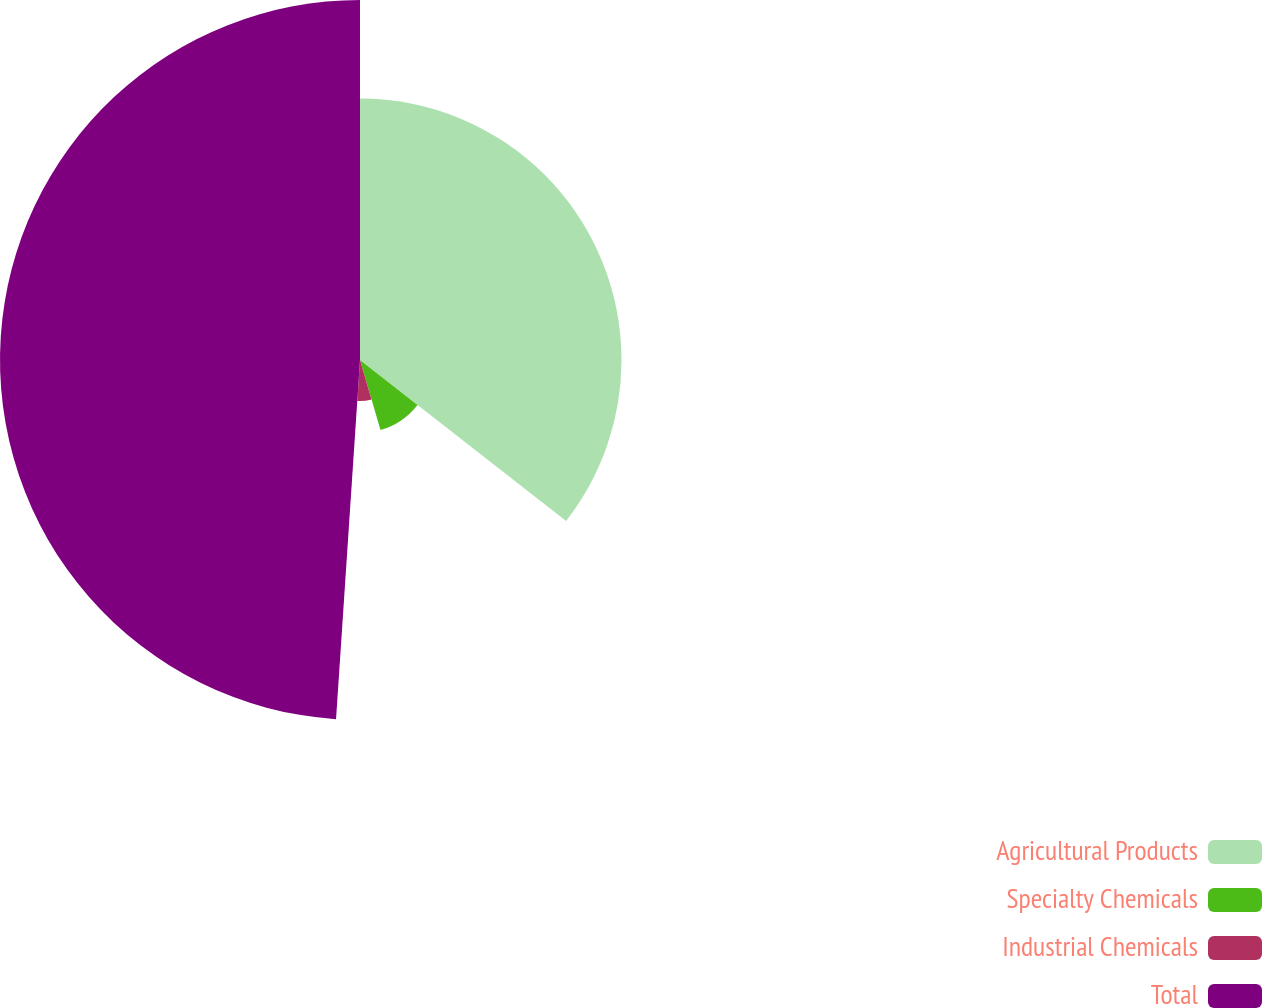Convert chart to OTSL. <chart><loc_0><loc_0><loc_500><loc_500><pie_chart><fcel>Agricultural Products<fcel>Specialty Chemicals<fcel>Industrial Chemicals<fcel>Total<nl><fcel>35.55%<fcel>9.92%<fcel>5.59%<fcel>48.94%<nl></chart> 